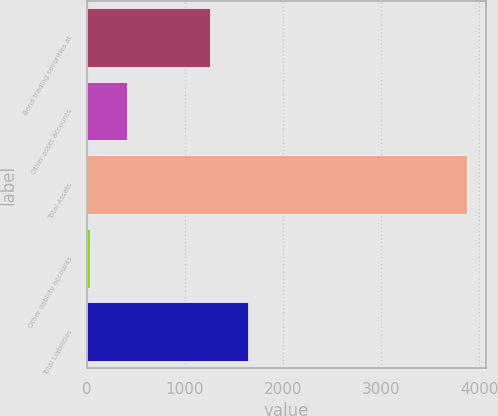Convert chart. <chart><loc_0><loc_0><loc_500><loc_500><bar_chart><fcel>Bond trading securities at<fcel>Other asset accounts<fcel>Total Assets<fcel>Other liability accounts<fcel>Total Liabilities<nl><fcel>1262<fcel>415.1<fcel>3872<fcel>31<fcel>1646.1<nl></chart> 